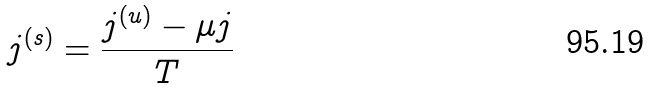Convert formula to latex. <formula><loc_0><loc_0><loc_500><loc_500>j ^ { ( s ) } = \frac { j ^ { ( u ) } - \mu j } { T }</formula> 